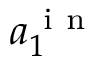Convert formula to latex. <formula><loc_0><loc_0><loc_500><loc_500>a _ { 1 } ^ { i n }</formula> 